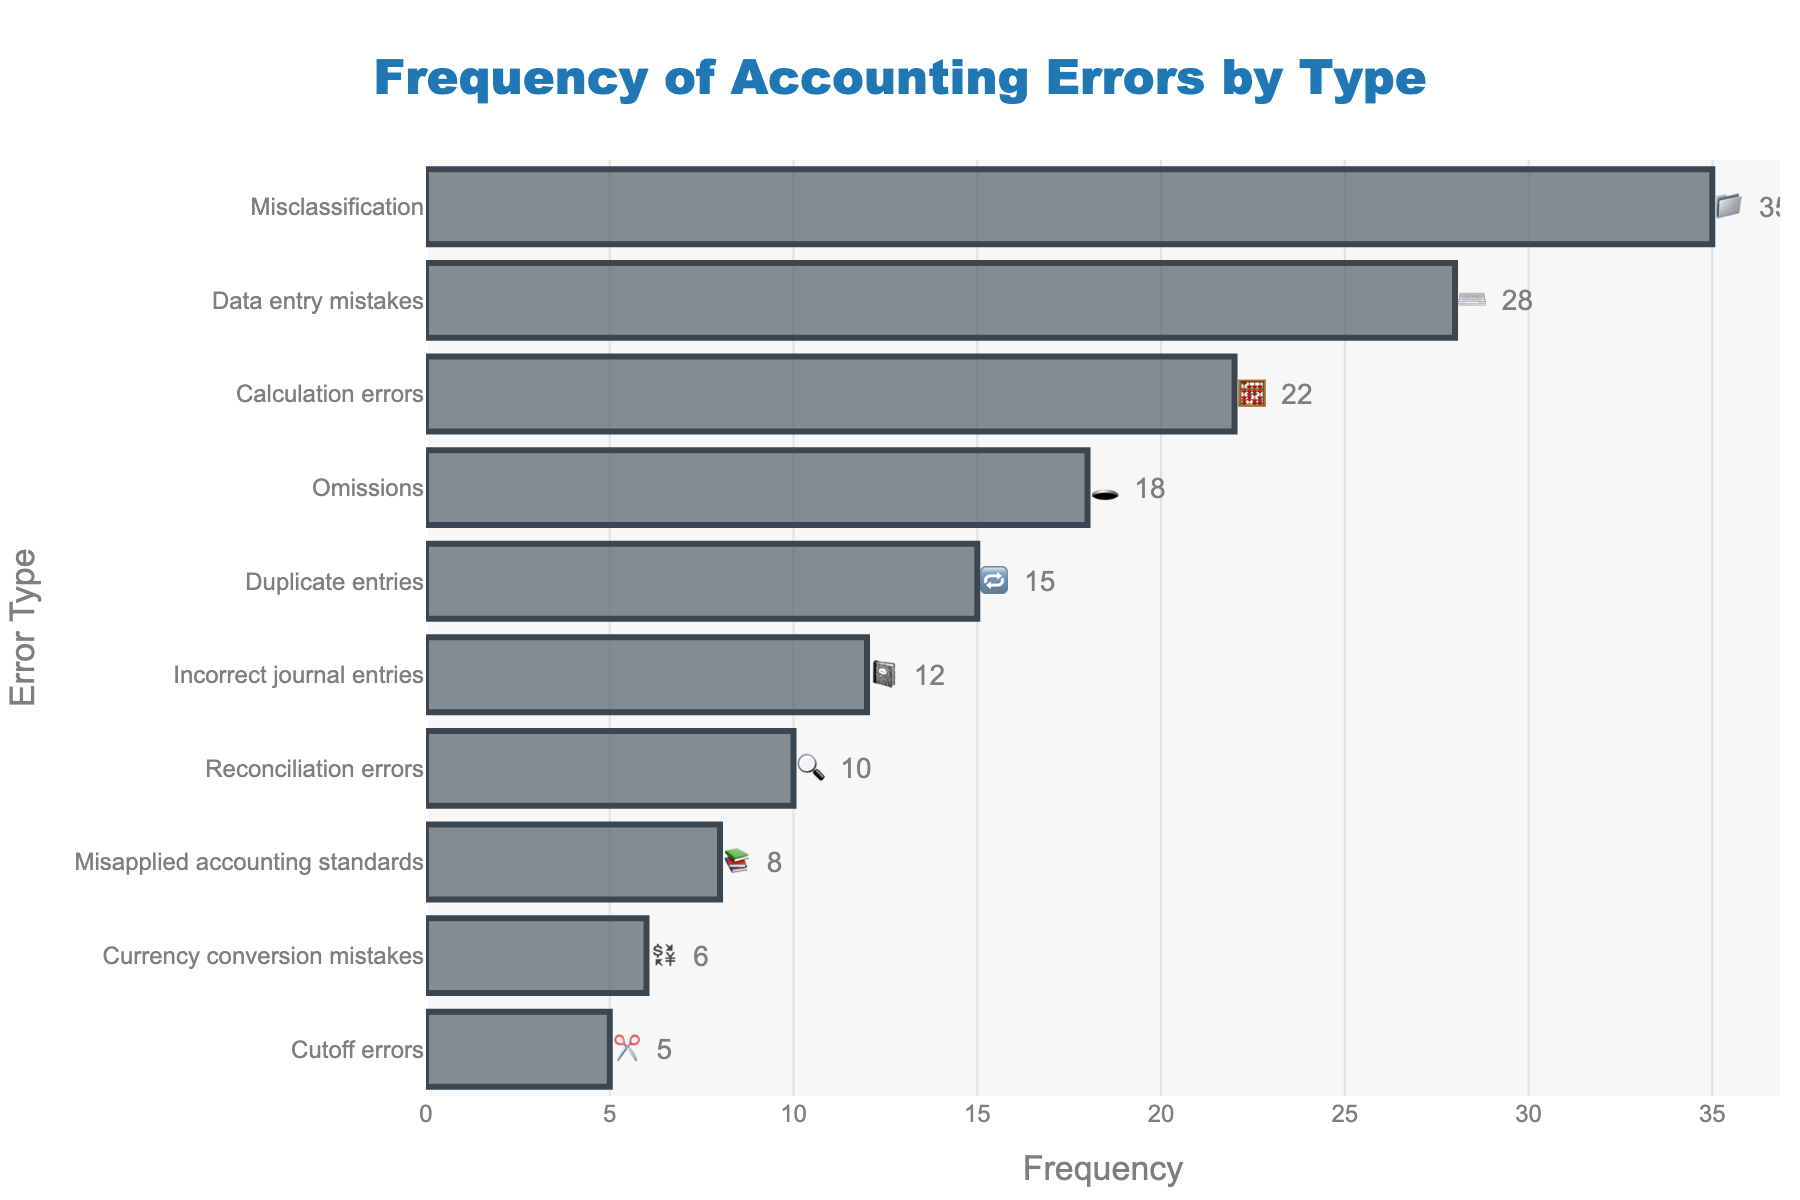What's the title of the chart? The title is typically displayed at the top center of the chart. It describes what the chart is about.
Answer: Frequency of Accounting Errors by Type How many types of accounting errors are shown in the chart? By counting each unique bar or label on the y-axis, we can determine the number of error types.
Answer: 10 Which accounting error has the highest frequency and which emoji represents it? Look at the bar with the longest length and its associated label and emoji.
Answer: Misclassification, 📁 What is the difference in frequency between Incorrect journal entries and Reconciliation errors? Find the frequencies of both errors and subtract the smaller from the larger one. Incorrect journal entries have 12, and Reconciliation errors have 10. The difference is 12 - 10.
Answer: 2 What is the combined frequency of the top three most common accounting errors? Identify the three bars with the highest frequencies and sum their values. Misclassification (35), Data entry mistakes (28), and Calculation errors (22). The combined frequency is 35 + 28 + 22.
Answer: 85 Between Currency conversion mistakes and Cutoff errors, which one occurs more frequently and by how much? Compare the lengths of the bars and their frequency values for both errors. Currency conversion mistakes have 6, Cutoff errors have 5. The difference is 6 - 5.
Answer: Currency conversion mistakes, by 1 Where is the text position for the frequency values displayed on the bars? Observe the placement of numeric values relative to the bars. The text is placed outside of the bar.
Answer: Outside What color are the bars in the chart? The bars' color is visually apparent in the chart.
Answer: rgba(58, 71, 80, 0.6) Which error type has the least frequency and which emoji represents it? Find the shortest bar and its associated label and emoji.
Answer: Cutoff errors, ✂️ How does the frequency of Data entry mistakes compare to that of Omissions? Look at the frequency values of both error types. Data entry mistakes have 28, and Omissions have 18. Data entry mistakes are more frequent by 10.
Answer: Data entry mistakes, by 10 